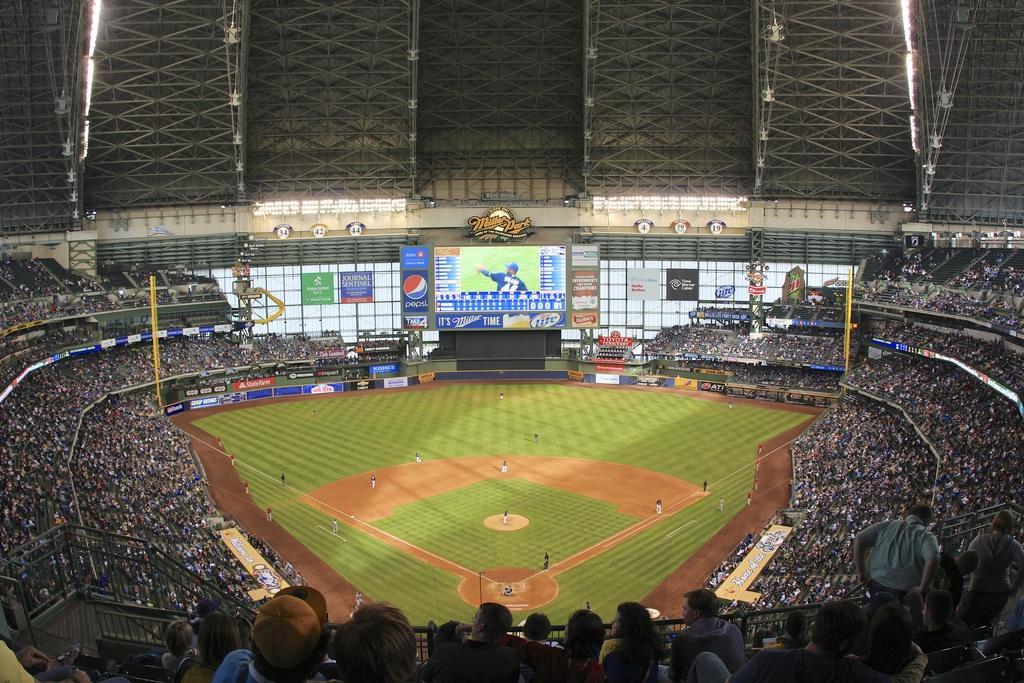Please provide a concise description of this image. In this image I can see number of persons are sitting in the stadium, the ground, few persons in the ground, a huge screen, the ceiling, number of metal rods and few lights to the ceiling. 